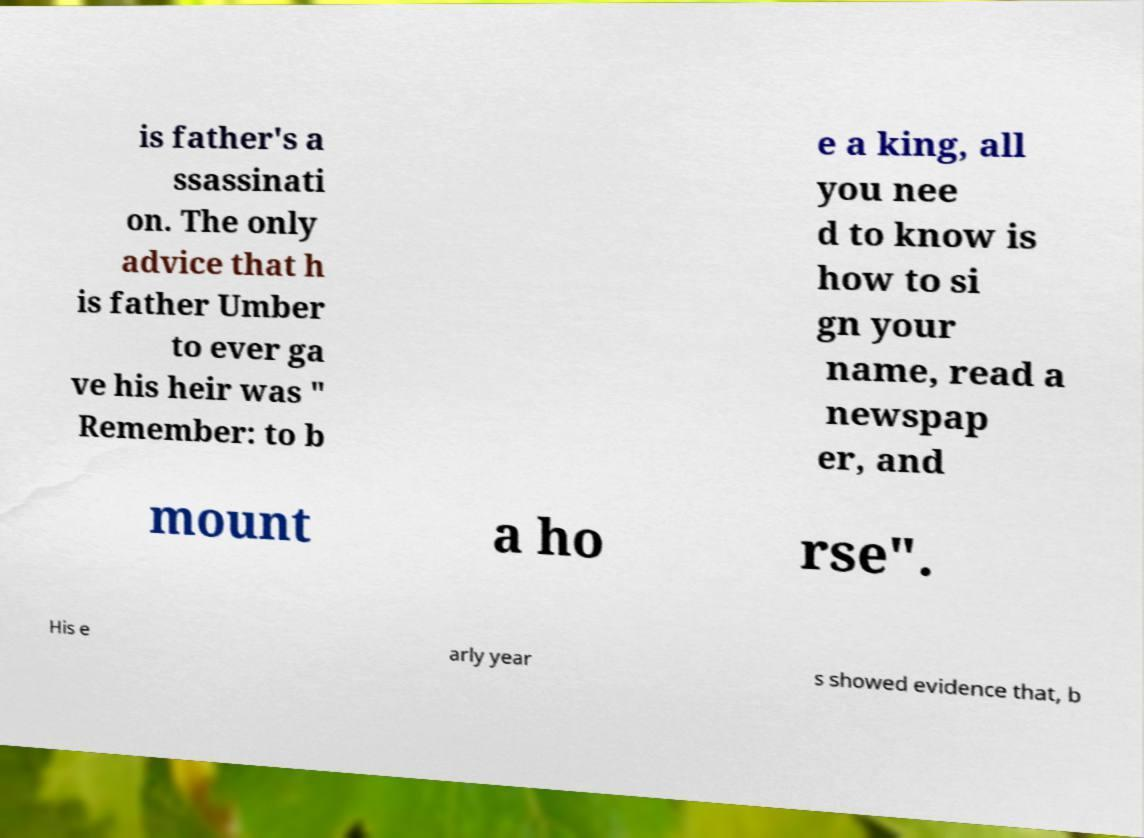Please identify and transcribe the text found in this image. is father's a ssassinati on. The only advice that h is father Umber to ever ga ve his heir was " Remember: to b e a king, all you nee d to know is how to si gn your name, read a newspap er, and mount a ho rse". His e arly year s showed evidence that, b 